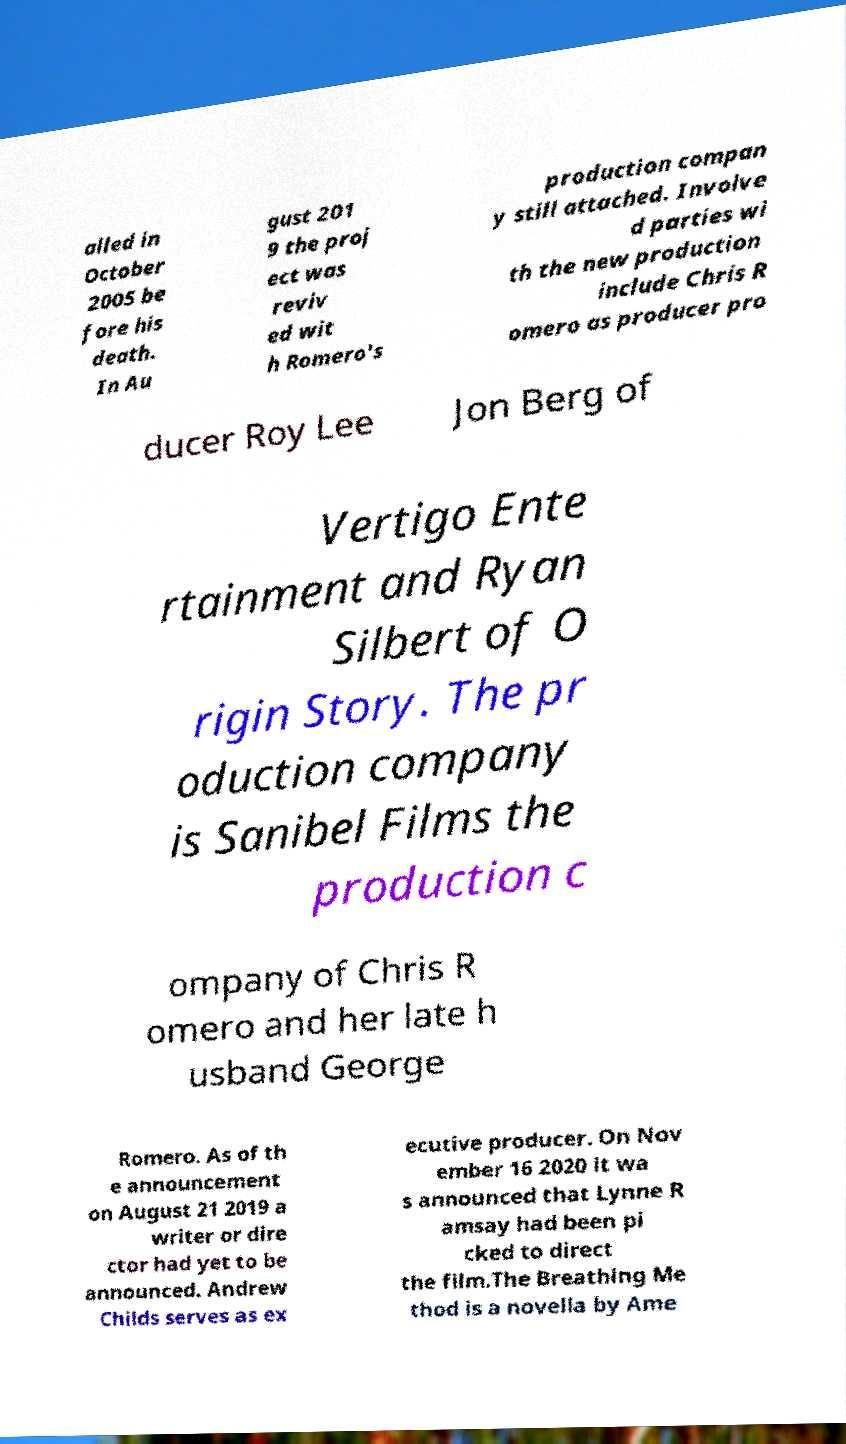Please identify and transcribe the text found in this image. alled in October 2005 be fore his death. In Au gust 201 9 the proj ect was reviv ed wit h Romero's production compan y still attached. Involve d parties wi th the new production include Chris R omero as producer pro ducer Roy Lee Jon Berg of Vertigo Ente rtainment and Ryan Silbert of O rigin Story. The pr oduction company is Sanibel Films the production c ompany of Chris R omero and her late h usband George Romero. As of th e announcement on August 21 2019 a writer or dire ctor had yet to be announced. Andrew Childs serves as ex ecutive producer. On Nov ember 16 2020 it wa s announced that Lynne R amsay had been pi cked to direct the film.The Breathing Me thod is a novella by Ame 